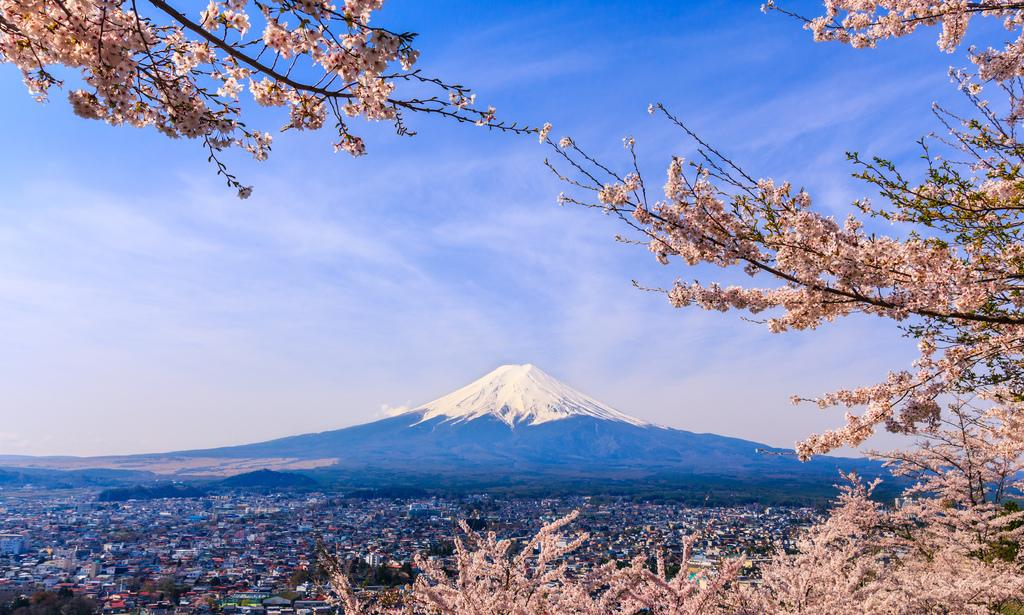What is located in the foreground of the image? There is a tree in the foreground of the image. What can be seen in the background of the image? There are houses and a mountain in the background of the image. What is visible in the sky in the image? The sky is visible in the background of the image, and clouds are present. Where can the porter be found in the image? There is no porter present in the image. What type of weather condition is depicted in the image? The image does not show any specific weather condition, but the presence of clouds in the sky suggests it might be a partly cloudy day. 